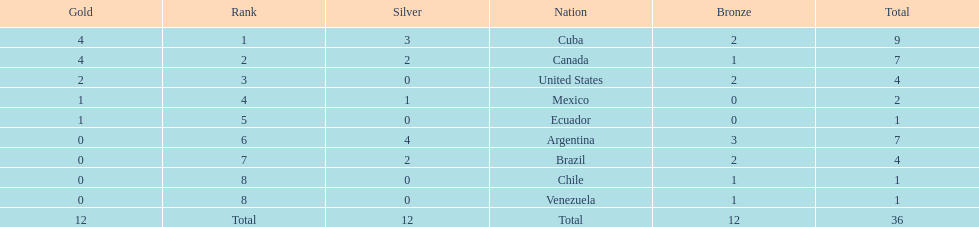Would you mind parsing the complete table? {'header': ['Gold', 'Rank', 'Silver', 'Nation', 'Bronze', 'Total'], 'rows': [['4', '1', '3', 'Cuba', '2', '9'], ['4', '2', '2', 'Canada', '1', '7'], ['2', '3', '0', 'United States', '2', '4'], ['1', '4', '1', 'Mexico', '0', '2'], ['1', '5', '0', 'Ecuador', '0', '1'], ['0', '6', '4', 'Argentina', '3', '7'], ['0', '7', '2', 'Brazil', '2', '4'], ['0', '8', '0', 'Chile', '1', '1'], ['0', '8', '0', 'Venezuela', '1', '1'], ['12', 'Total', '12', 'Total', '12', '36']]} Which country won the largest haul of bronze medals? Argentina. 